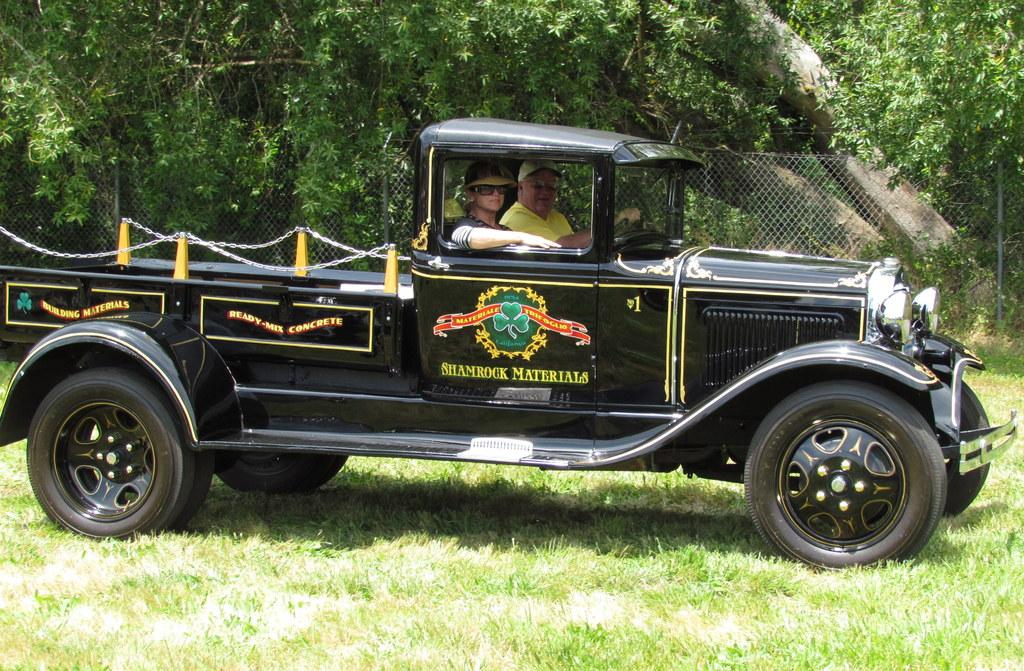What type of vehicle is in the foreground of the image? There is a black color truck in the foreground of the image. Who is inside the truck? Two men are sitting inside the truck. Where is the truck located? The truck is on the grass. What can be seen in the background of the image? There is a fencing and trees present in the background of the image. What type of yam is being used as a weapon in the battle depicted in the image? There is no battle or yam present in the image; it features a black color truck on the grass with two men inside. What kind of art can be seen on the side of the truck in the image? There is no art or decoration visible on the truck in the image. 